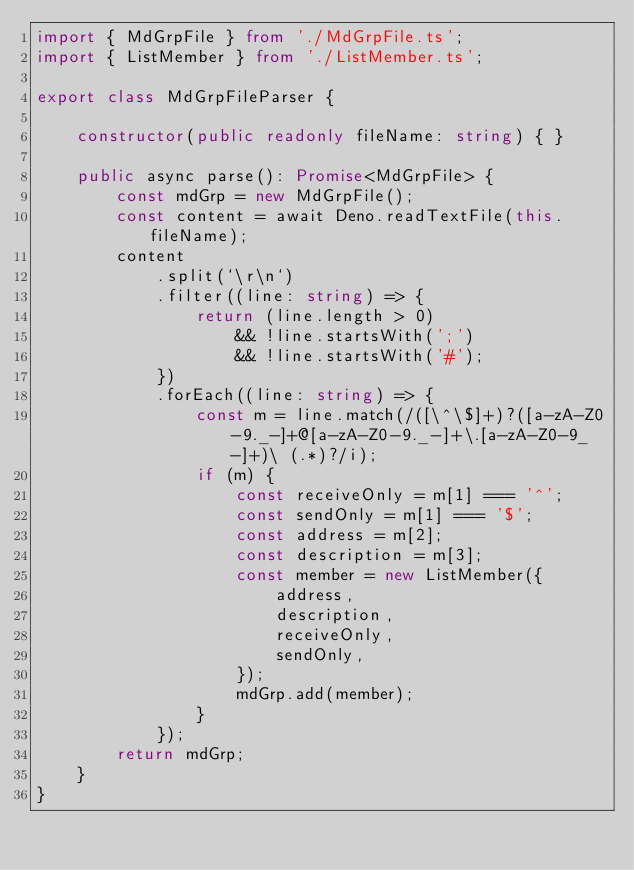<code> <loc_0><loc_0><loc_500><loc_500><_TypeScript_>import { MdGrpFile } from './MdGrpFile.ts';
import { ListMember } from './ListMember.ts';

export class MdGrpFileParser {

    constructor(public readonly fileName: string) { }

    public async parse(): Promise<MdGrpFile> {
        const mdGrp = new MdGrpFile();
        const content = await Deno.readTextFile(this.fileName);
        content
            .split(`\r\n`)
            .filter((line: string) => {
                return (line.length > 0)
                    && !line.startsWith(';')
                    && !line.startsWith('#');
            })
            .forEach((line: string) => {
                const m = line.match(/([\^\$]+)?([a-zA-Z0-9._-]+@[a-zA-Z0-9._-]+\.[a-zA-Z0-9_-]+)\ (.*)?/i);
                if (m) {
                    const receiveOnly = m[1] === '^';
                    const sendOnly = m[1] === '$';
                    const address = m[2];
                    const description = m[3];
                    const member = new ListMember({
                        address,
                        description,
                        receiveOnly,
                        sendOnly,
                    });
                    mdGrp.add(member);
                }
            });
        return mdGrp;
    }
}</code> 